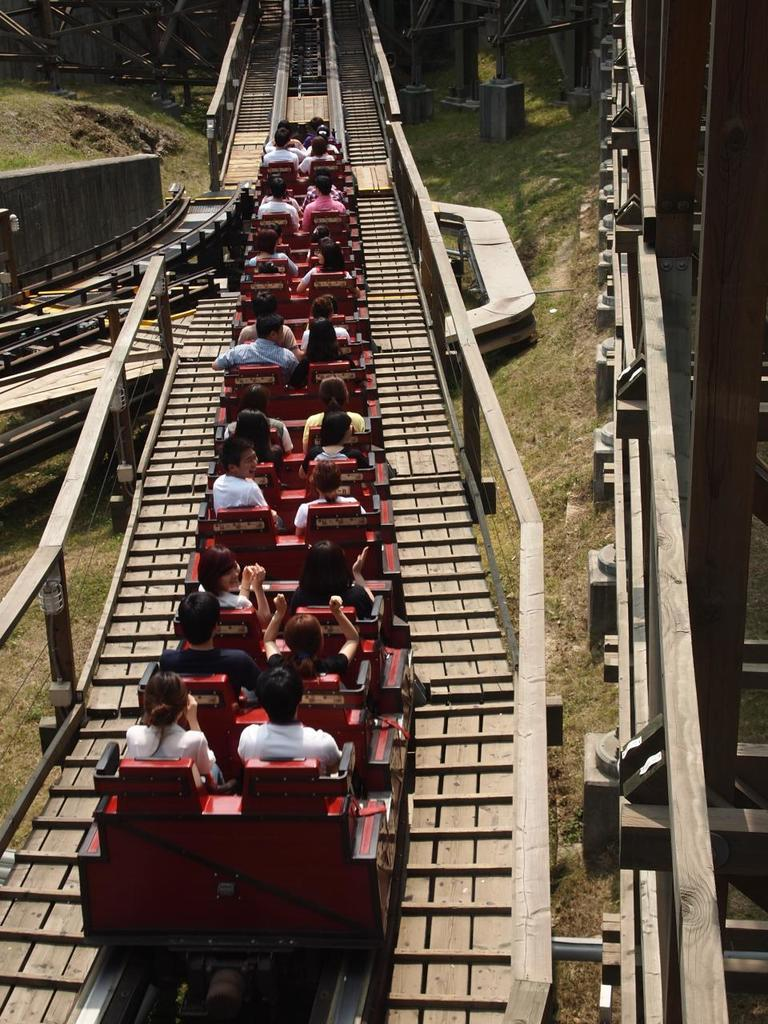What are the persons in the image doing? The persons in the image are sitting in the seats of a roller coaster. What type of structure can be seen in the image? Iron grills are visible in the image. What is the roller coaster resting on? Tracks are present in the image, which the roller coaster is resting on. What is visible beneath the roller coaster? The ground is visible in the image. How long does it take for the cow to wash its face in the image? There is no cow present in the image, and therefore no such activity can be observed. 